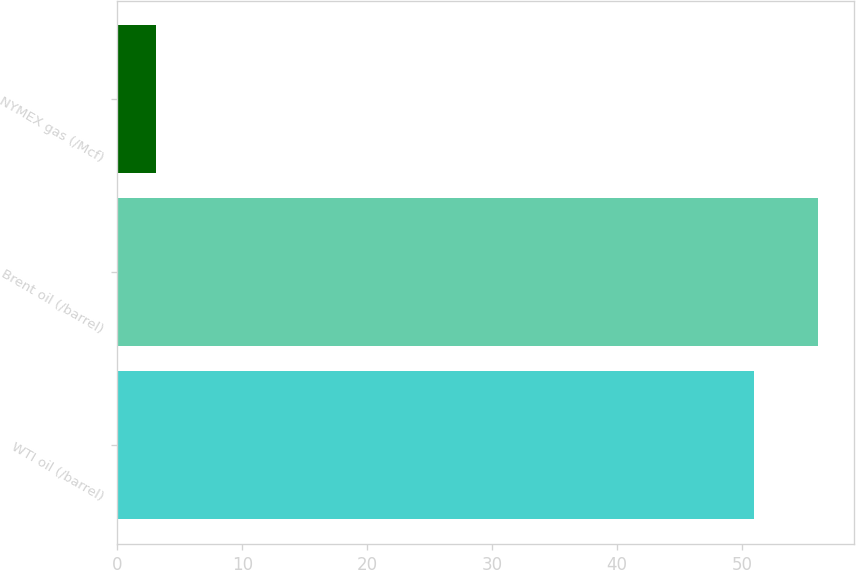Convert chart to OTSL. <chart><loc_0><loc_0><loc_500><loc_500><bar_chart><fcel>WTI oil (/barrel)<fcel>Brent oil (/barrel)<fcel>NYMEX gas (/Mcf)<nl><fcel>50.95<fcel>56.12<fcel>3.09<nl></chart> 